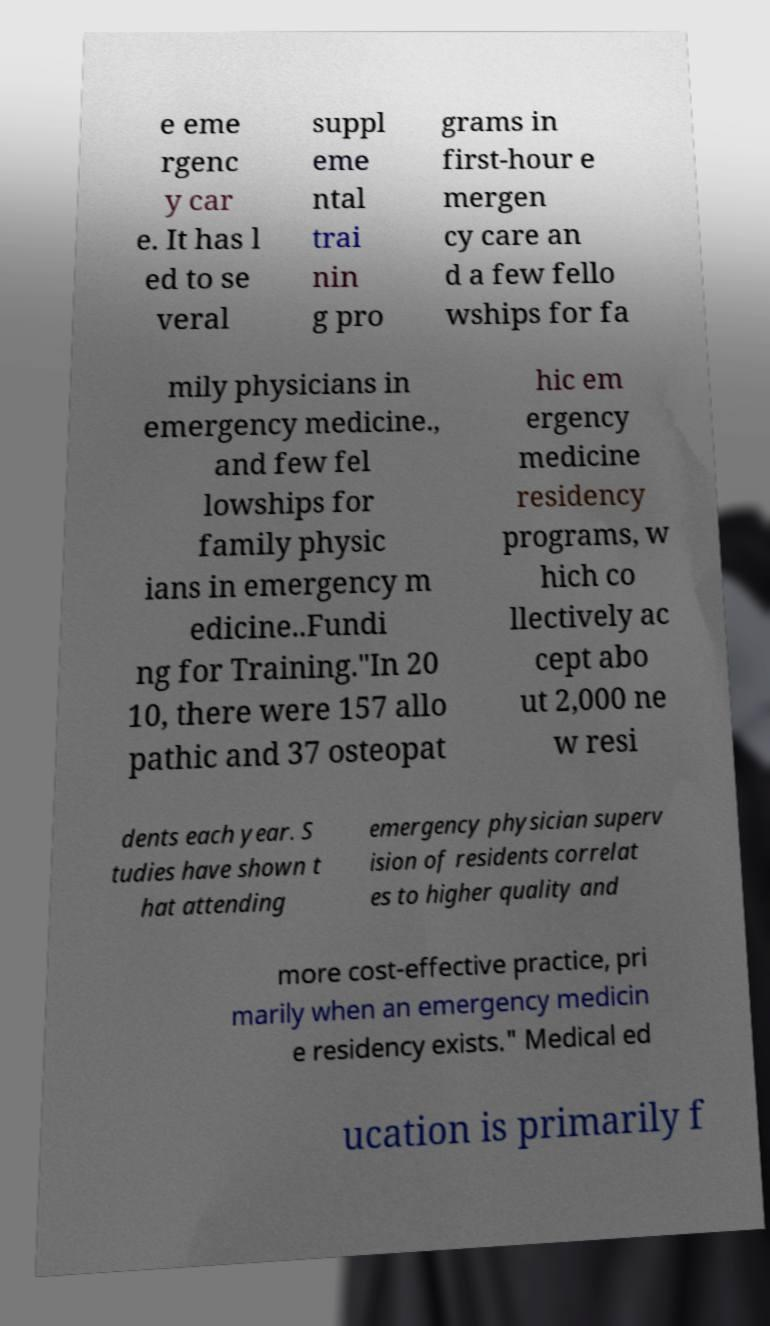What messages or text are displayed in this image? I need them in a readable, typed format. e eme rgenc y car e. It has l ed to se veral suppl eme ntal trai nin g pro grams in first-hour e mergen cy care an d a few fello wships for fa mily physicians in emergency medicine., and few fel lowships for family physic ians in emergency m edicine..Fundi ng for Training."In 20 10, there were 157 allo pathic and 37 osteopat hic em ergency medicine residency programs, w hich co llectively ac cept abo ut 2,000 ne w resi dents each year. S tudies have shown t hat attending emergency physician superv ision of residents correlat es to higher quality and more cost-effective practice, pri marily when an emergency medicin e residency exists." Medical ed ucation is primarily f 